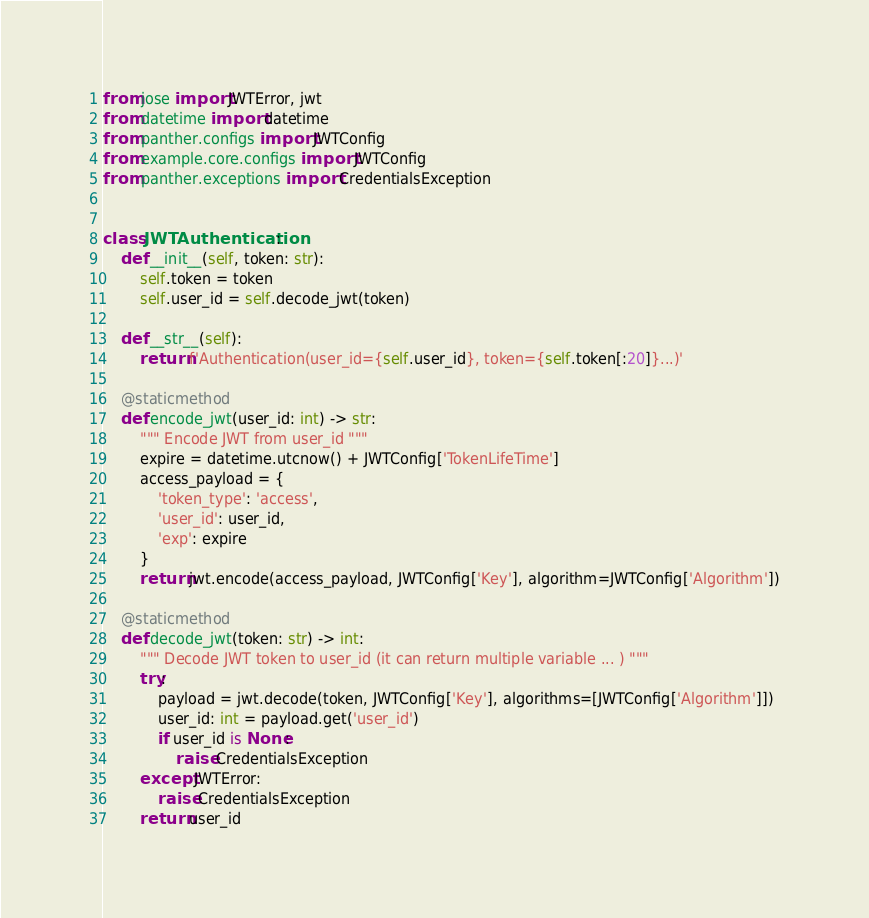Convert code to text. <code><loc_0><loc_0><loc_500><loc_500><_Python_>from jose import JWTError, jwt
from datetime import datetime
from panther.configs import JWTConfig
from example.core.configs import JWTConfig
from panther.exceptions import CredentialsException


class JWTAuthentication:
    def __init__(self, token: str):
        self.token = token
        self.user_id = self.decode_jwt(token)

    def __str__(self):
        return f'Authentication(user_id={self.user_id}, token={self.token[:20]}...)'

    @staticmethod
    def encode_jwt(user_id: int) -> str:
        """ Encode JWT from user_id """
        expire = datetime.utcnow() + JWTConfig['TokenLifeTime']
        access_payload = {
            'token_type': 'access',
            'user_id': user_id,
            'exp': expire
        }
        return jwt.encode(access_payload, JWTConfig['Key'], algorithm=JWTConfig['Algorithm'])

    @staticmethod
    def decode_jwt(token: str) -> int:
        """ Decode JWT token to user_id (it can return multiple variable ... ) """
        try:
            payload = jwt.decode(token, JWTConfig['Key'], algorithms=[JWTConfig['Algorithm']])
            user_id: int = payload.get('user_id')
            if user_id is None:
                raise CredentialsException
        except JWTError:
            raise CredentialsException
        return user_id
</code> 